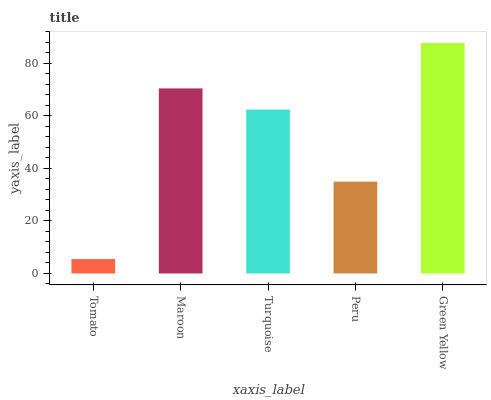Is Tomato the minimum?
Answer yes or no. Yes. Is Green Yellow the maximum?
Answer yes or no. Yes. Is Maroon the minimum?
Answer yes or no. No. Is Maroon the maximum?
Answer yes or no. No. Is Maroon greater than Tomato?
Answer yes or no. Yes. Is Tomato less than Maroon?
Answer yes or no. Yes. Is Tomato greater than Maroon?
Answer yes or no. No. Is Maroon less than Tomato?
Answer yes or no. No. Is Turquoise the high median?
Answer yes or no. Yes. Is Turquoise the low median?
Answer yes or no. Yes. Is Peru the high median?
Answer yes or no. No. Is Tomato the low median?
Answer yes or no. No. 